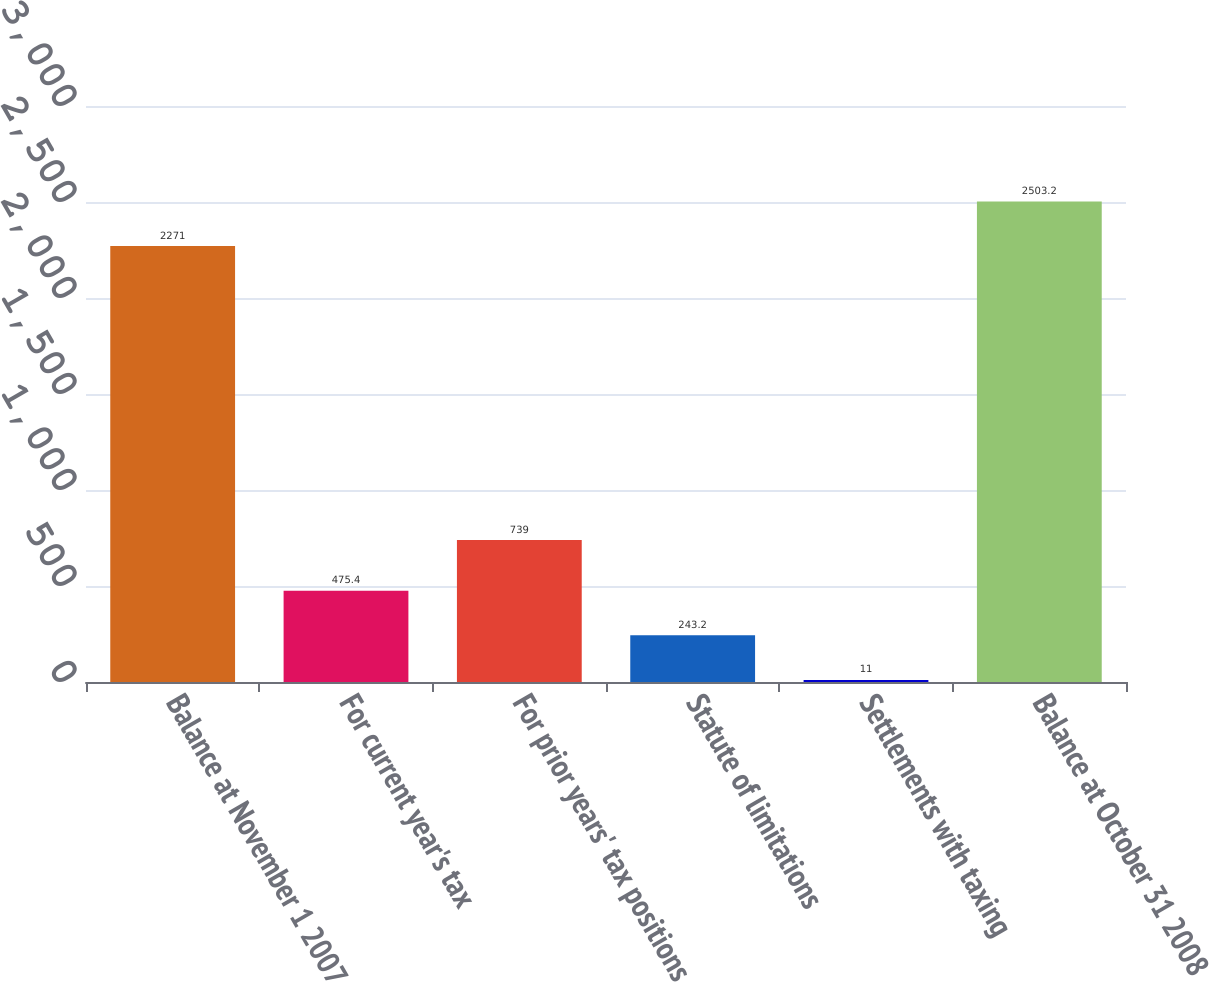Convert chart. <chart><loc_0><loc_0><loc_500><loc_500><bar_chart><fcel>Balance at November 1 2007<fcel>For current year's tax<fcel>For prior years' tax positions<fcel>Statute of limitations<fcel>Settlements with taxing<fcel>Balance at October 31 2008<nl><fcel>2271<fcel>475.4<fcel>739<fcel>243.2<fcel>11<fcel>2503.2<nl></chart> 